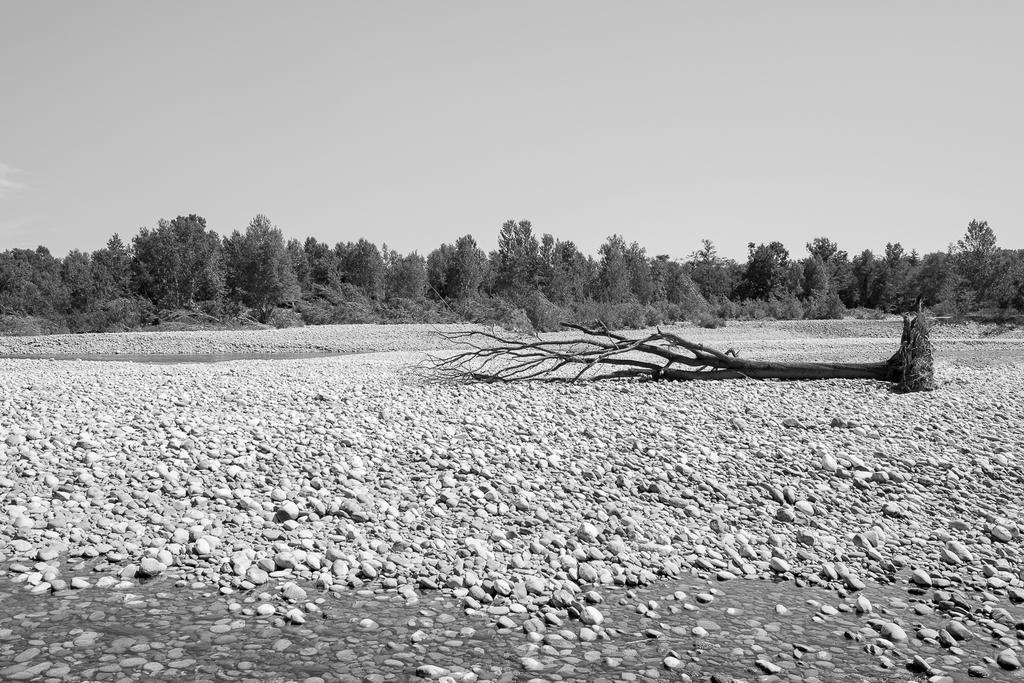What type of natural elements can be seen in the image? There are rocks in the image. What can be seen in the background of the image? There are trees in the background of the image. What type of honey is being produced by the society in the image? There is no society or honey production present in the image; it features rocks and trees. 